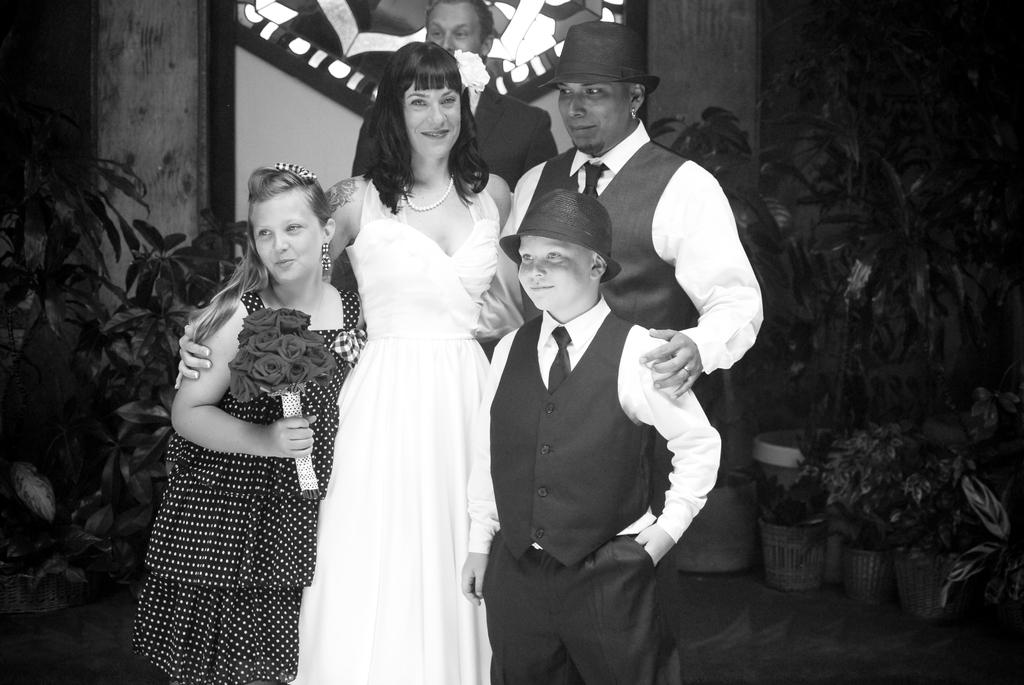Where is the boy located in the image? The boy is standing on the right side of the image. What is the boy wearing in the image? The boy is wearing a black coat. Can you describe the woman in the image? There is a beautiful woman standing in the image, and she is wearing a white dress. What can be seen on either side of the boy and woman? There are plants on either side of the boy and woman. What type of necklace is the worm wearing in the image? There is no worm or necklace present in the image. Can you describe the dog's behavior in the image? There is no dog present in the image. 